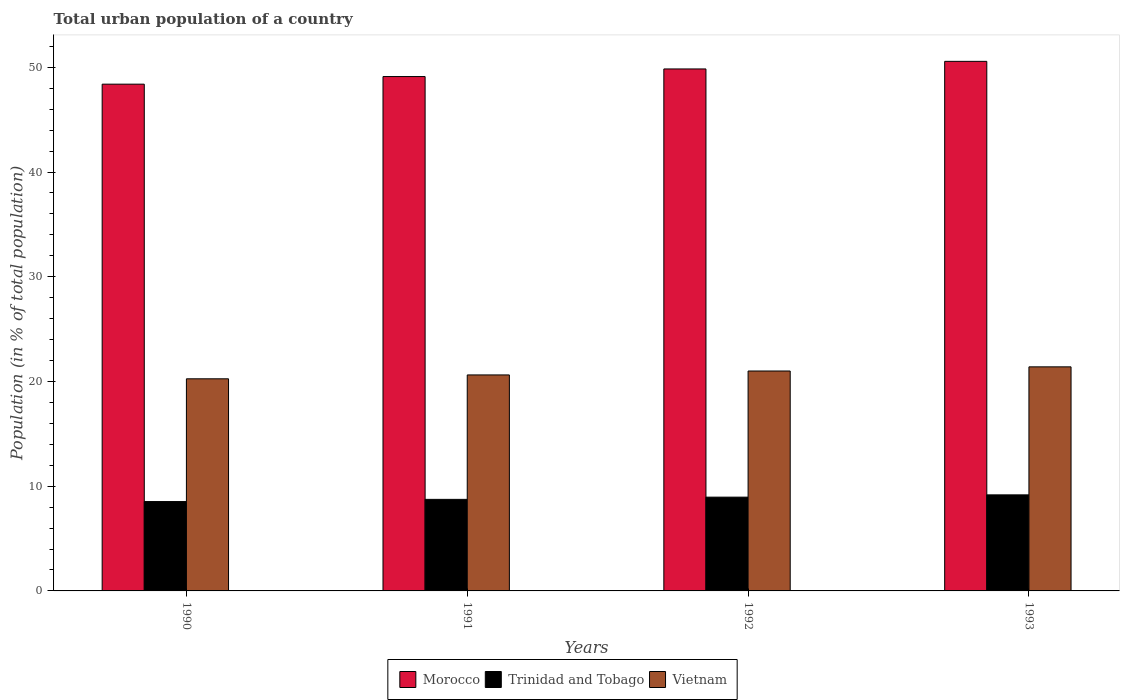How many different coloured bars are there?
Offer a terse response. 3. Are the number of bars per tick equal to the number of legend labels?
Make the answer very short. Yes. How many bars are there on the 3rd tick from the right?
Give a very brief answer. 3. What is the urban population in Morocco in 1991?
Offer a very short reply. 49.12. Across all years, what is the maximum urban population in Vietnam?
Offer a very short reply. 21.4. Across all years, what is the minimum urban population in Trinidad and Tobago?
Offer a terse response. 8.53. What is the total urban population in Trinidad and Tobago in the graph?
Your answer should be very brief. 35.4. What is the difference between the urban population in Vietnam in 1991 and that in 1993?
Your response must be concise. -0.77. What is the difference between the urban population in Vietnam in 1992 and the urban population in Trinidad and Tobago in 1993?
Your answer should be very brief. 11.83. What is the average urban population in Vietnam per year?
Your response must be concise. 20.82. In the year 1991, what is the difference between the urban population in Morocco and urban population in Trinidad and Tobago?
Give a very brief answer. 40.38. In how many years, is the urban population in Morocco greater than 50 %?
Give a very brief answer. 1. What is the ratio of the urban population in Trinidad and Tobago in 1992 to that in 1993?
Your answer should be compact. 0.98. Is the urban population in Vietnam in 1990 less than that in 1993?
Your answer should be very brief. Yes. What is the difference between the highest and the second highest urban population in Morocco?
Offer a very short reply. 0.73. What is the difference between the highest and the lowest urban population in Trinidad and Tobago?
Give a very brief answer. 0.64. Is the sum of the urban population in Trinidad and Tobago in 1992 and 1993 greater than the maximum urban population in Morocco across all years?
Your response must be concise. No. What does the 1st bar from the left in 1993 represents?
Your response must be concise. Morocco. What does the 3rd bar from the right in 1993 represents?
Keep it short and to the point. Morocco. Is it the case that in every year, the sum of the urban population in Vietnam and urban population in Trinidad and Tobago is greater than the urban population in Morocco?
Ensure brevity in your answer.  No. How many bars are there?
Make the answer very short. 12. What is the difference between two consecutive major ticks on the Y-axis?
Your answer should be compact. 10. Are the values on the major ticks of Y-axis written in scientific E-notation?
Your answer should be very brief. No. How many legend labels are there?
Offer a very short reply. 3. What is the title of the graph?
Provide a succinct answer. Total urban population of a country. What is the label or title of the Y-axis?
Provide a short and direct response. Population (in % of total population). What is the Population (in % of total population) in Morocco in 1990?
Offer a very short reply. 48.39. What is the Population (in % of total population) of Trinidad and Tobago in 1990?
Keep it short and to the point. 8.53. What is the Population (in % of total population) in Vietnam in 1990?
Your answer should be very brief. 20.25. What is the Population (in % of total population) in Morocco in 1991?
Offer a very short reply. 49.12. What is the Population (in % of total population) in Trinidad and Tobago in 1991?
Offer a very short reply. 8.74. What is the Population (in % of total population) in Vietnam in 1991?
Ensure brevity in your answer.  20.62. What is the Population (in % of total population) in Morocco in 1992?
Your answer should be very brief. 49.84. What is the Population (in % of total population) in Trinidad and Tobago in 1992?
Ensure brevity in your answer.  8.96. What is the Population (in % of total population) in Morocco in 1993?
Ensure brevity in your answer.  50.57. What is the Population (in % of total population) of Trinidad and Tobago in 1993?
Your response must be concise. 9.17. What is the Population (in % of total population) in Vietnam in 1993?
Your answer should be compact. 21.4. Across all years, what is the maximum Population (in % of total population) of Morocco?
Provide a succinct answer. 50.57. Across all years, what is the maximum Population (in % of total population) of Trinidad and Tobago?
Your answer should be very brief. 9.17. Across all years, what is the maximum Population (in % of total population) in Vietnam?
Make the answer very short. 21.4. Across all years, what is the minimum Population (in % of total population) in Morocco?
Your answer should be very brief. 48.39. Across all years, what is the minimum Population (in % of total population) in Trinidad and Tobago?
Offer a very short reply. 8.53. Across all years, what is the minimum Population (in % of total population) in Vietnam?
Offer a terse response. 20.25. What is the total Population (in % of total population) in Morocco in the graph?
Give a very brief answer. 197.92. What is the total Population (in % of total population) in Trinidad and Tobago in the graph?
Your answer should be compact. 35.4. What is the total Population (in % of total population) of Vietnam in the graph?
Your answer should be compact. 83.28. What is the difference between the Population (in % of total population) in Morocco in 1990 and that in 1991?
Offer a very short reply. -0.73. What is the difference between the Population (in % of total population) in Trinidad and Tobago in 1990 and that in 1991?
Offer a very short reply. -0.21. What is the difference between the Population (in % of total population) in Vietnam in 1990 and that in 1991?
Your response must be concise. -0.37. What is the difference between the Population (in % of total population) in Morocco in 1990 and that in 1992?
Ensure brevity in your answer.  -1.45. What is the difference between the Population (in % of total population) in Trinidad and Tobago in 1990 and that in 1992?
Provide a succinct answer. -0.42. What is the difference between the Population (in % of total population) in Vietnam in 1990 and that in 1992?
Offer a terse response. -0.74. What is the difference between the Population (in % of total population) of Morocco in 1990 and that in 1993?
Provide a succinct answer. -2.18. What is the difference between the Population (in % of total population) in Trinidad and Tobago in 1990 and that in 1993?
Your answer should be very brief. -0.64. What is the difference between the Population (in % of total population) in Vietnam in 1990 and that in 1993?
Offer a terse response. -1.14. What is the difference between the Population (in % of total population) of Morocco in 1991 and that in 1992?
Your response must be concise. -0.73. What is the difference between the Population (in % of total population) of Trinidad and Tobago in 1991 and that in 1992?
Your answer should be very brief. -0.21. What is the difference between the Population (in % of total population) in Vietnam in 1991 and that in 1992?
Your answer should be compact. -0.38. What is the difference between the Population (in % of total population) of Morocco in 1991 and that in 1993?
Keep it short and to the point. -1.45. What is the difference between the Population (in % of total population) in Trinidad and Tobago in 1991 and that in 1993?
Provide a succinct answer. -0.43. What is the difference between the Population (in % of total population) of Vietnam in 1991 and that in 1993?
Offer a terse response. -0.77. What is the difference between the Population (in % of total population) of Morocco in 1992 and that in 1993?
Provide a short and direct response. -0.72. What is the difference between the Population (in % of total population) in Trinidad and Tobago in 1992 and that in 1993?
Your answer should be very brief. -0.22. What is the difference between the Population (in % of total population) of Vietnam in 1992 and that in 1993?
Make the answer very short. -0.4. What is the difference between the Population (in % of total population) of Morocco in 1990 and the Population (in % of total population) of Trinidad and Tobago in 1991?
Provide a short and direct response. 39.65. What is the difference between the Population (in % of total population) in Morocco in 1990 and the Population (in % of total population) in Vietnam in 1991?
Offer a very short reply. 27.77. What is the difference between the Population (in % of total population) in Trinidad and Tobago in 1990 and the Population (in % of total population) in Vietnam in 1991?
Your answer should be compact. -12.09. What is the difference between the Population (in % of total population) in Morocco in 1990 and the Population (in % of total population) in Trinidad and Tobago in 1992?
Make the answer very short. 39.44. What is the difference between the Population (in % of total population) in Morocco in 1990 and the Population (in % of total population) in Vietnam in 1992?
Offer a very short reply. 27.39. What is the difference between the Population (in % of total population) in Trinidad and Tobago in 1990 and the Population (in % of total population) in Vietnam in 1992?
Offer a very short reply. -12.47. What is the difference between the Population (in % of total population) of Morocco in 1990 and the Population (in % of total population) of Trinidad and Tobago in 1993?
Ensure brevity in your answer.  39.22. What is the difference between the Population (in % of total population) of Morocco in 1990 and the Population (in % of total population) of Vietnam in 1993?
Provide a succinct answer. 26.99. What is the difference between the Population (in % of total population) of Trinidad and Tobago in 1990 and the Population (in % of total population) of Vietnam in 1993?
Offer a very short reply. -12.86. What is the difference between the Population (in % of total population) in Morocco in 1991 and the Population (in % of total population) in Trinidad and Tobago in 1992?
Provide a succinct answer. 40.16. What is the difference between the Population (in % of total population) in Morocco in 1991 and the Population (in % of total population) in Vietnam in 1992?
Give a very brief answer. 28.12. What is the difference between the Population (in % of total population) of Trinidad and Tobago in 1991 and the Population (in % of total population) of Vietnam in 1992?
Provide a short and direct response. -12.26. What is the difference between the Population (in % of total population) in Morocco in 1991 and the Population (in % of total population) in Trinidad and Tobago in 1993?
Your answer should be compact. 39.94. What is the difference between the Population (in % of total population) of Morocco in 1991 and the Population (in % of total population) of Vietnam in 1993?
Your response must be concise. 27.72. What is the difference between the Population (in % of total population) in Trinidad and Tobago in 1991 and the Population (in % of total population) in Vietnam in 1993?
Make the answer very short. -12.65. What is the difference between the Population (in % of total population) of Morocco in 1992 and the Population (in % of total population) of Trinidad and Tobago in 1993?
Give a very brief answer. 40.67. What is the difference between the Population (in % of total population) of Morocco in 1992 and the Population (in % of total population) of Vietnam in 1993?
Provide a short and direct response. 28.45. What is the difference between the Population (in % of total population) in Trinidad and Tobago in 1992 and the Population (in % of total population) in Vietnam in 1993?
Keep it short and to the point. -12.44. What is the average Population (in % of total population) in Morocco per year?
Your answer should be very brief. 49.48. What is the average Population (in % of total population) of Trinidad and Tobago per year?
Provide a short and direct response. 8.85. What is the average Population (in % of total population) of Vietnam per year?
Your response must be concise. 20.82. In the year 1990, what is the difference between the Population (in % of total population) of Morocco and Population (in % of total population) of Trinidad and Tobago?
Provide a short and direct response. 39.86. In the year 1990, what is the difference between the Population (in % of total population) of Morocco and Population (in % of total population) of Vietnam?
Make the answer very short. 28.14. In the year 1990, what is the difference between the Population (in % of total population) in Trinidad and Tobago and Population (in % of total population) in Vietnam?
Make the answer very short. -11.72. In the year 1991, what is the difference between the Population (in % of total population) of Morocco and Population (in % of total population) of Trinidad and Tobago?
Give a very brief answer. 40.38. In the year 1991, what is the difference between the Population (in % of total population) in Morocco and Population (in % of total population) in Vietnam?
Keep it short and to the point. 28.49. In the year 1991, what is the difference between the Population (in % of total population) in Trinidad and Tobago and Population (in % of total population) in Vietnam?
Make the answer very short. -11.88. In the year 1992, what is the difference between the Population (in % of total population) of Morocco and Population (in % of total population) of Trinidad and Tobago?
Provide a succinct answer. 40.89. In the year 1992, what is the difference between the Population (in % of total population) in Morocco and Population (in % of total population) in Vietnam?
Keep it short and to the point. 28.84. In the year 1992, what is the difference between the Population (in % of total population) in Trinidad and Tobago and Population (in % of total population) in Vietnam?
Provide a short and direct response. -12.04. In the year 1993, what is the difference between the Population (in % of total population) in Morocco and Population (in % of total population) in Trinidad and Tobago?
Your answer should be compact. 41.4. In the year 1993, what is the difference between the Population (in % of total population) of Morocco and Population (in % of total population) of Vietnam?
Your answer should be very brief. 29.17. In the year 1993, what is the difference between the Population (in % of total population) of Trinidad and Tobago and Population (in % of total population) of Vietnam?
Offer a very short reply. -12.22. What is the ratio of the Population (in % of total population) in Morocco in 1990 to that in 1991?
Offer a terse response. 0.99. What is the ratio of the Population (in % of total population) of Trinidad and Tobago in 1990 to that in 1991?
Your response must be concise. 0.98. What is the ratio of the Population (in % of total population) of Vietnam in 1990 to that in 1991?
Your response must be concise. 0.98. What is the ratio of the Population (in % of total population) of Morocco in 1990 to that in 1992?
Give a very brief answer. 0.97. What is the ratio of the Population (in % of total population) in Trinidad and Tobago in 1990 to that in 1992?
Keep it short and to the point. 0.95. What is the ratio of the Population (in % of total population) in Vietnam in 1990 to that in 1992?
Provide a succinct answer. 0.96. What is the ratio of the Population (in % of total population) of Morocco in 1990 to that in 1993?
Keep it short and to the point. 0.96. What is the ratio of the Population (in % of total population) in Trinidad and Tobago in 1990 to that in 1993?
Your response must be concise. 0.93. What is the ratio of the Population (in % of total population) in Vietnam in 1990 to that in 1993?
Ensure brevity in your answer.  0.95. What is the ratio of the Population (in % of total population) in Morocco in 1991 to that in 1992?
Keep it short and to the point. 0.99. What is the ratio of the Population (in % of total population) of Trinidad and Tobago in 1991 to that in 1992?
Give a very brief answer. 0.98. What is the ratio of the Population (in % of total population) in Vietnam in 1991 to that in 1992?
Provide a short and direct response. 0.98. What is the ratio of the Population (in % of total population) in Morocco in 1991 to that in 1993?
Provide a succinct answer. 0.97. What is the ratio of the Population (in % of total population) in Trinidad and Tobago in 1991 to that in 1993?
Give a very brief answer. 0.95. What is the ratio of the Population (in % of total population) in Vietnam in 1991 to that in 1993?
Your response must be concise. 0.96. What is the ratio of the Population (in % of total population) in Morocco in 1992 to that in 1993?
Offer a terse response. 0.99. What is the ratio of the Population (in % of total population) of Trinidad and Tobago in 1992 to that in 1993?
Your answer should be compact. 0.98. What is the ratio of the Population (in % of total population) in Vietnam in 1992 to that in 1993?
Provide a succinct answer. 0.98. What is the difference between the highest and the second highest Population (in % of total population) in Morocco?
Offer a terse response. 0.72. What is the difference between the highest and the second highest Population (in % of total population) of Trinidad and Tobago?
Make the answer very short. 0.22. What is the difference between the highest and the second highest Population (in % of total population) of Vietnam?
Provide a succinct answer. 0.4. What is the difference between the highest and the lowest Population (in % of total population) in Morocco?
Offer a terse response. 2.18. What is the difference between the highest and the lowest Population (in % of total population) of Trinidad and Tobago?
Your answer should be very brief. 0.64. What is the difference between the highest and the lowest Population (in % of total population) in Vietnam?
Your answer should be very brief. 1.14. 